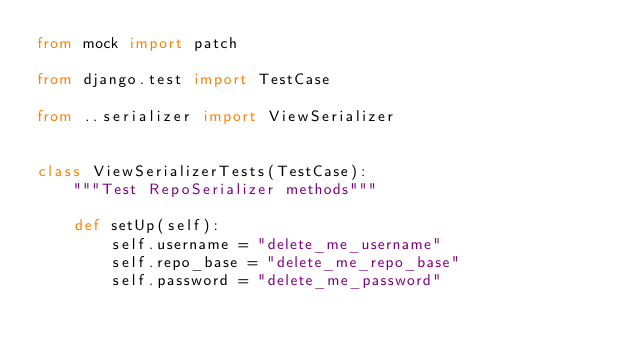Convert code to text. <code><loc_0><loc_0><loc_500><loc_500><_Python_>from mock import patch

from django.test import TestCase

from ..serializer import ViewSerializer


class ViewSerializerTests(TestCase):
    """Test RepoSerializer methods"""

    def setUp(self):
        self.username = "delete_me_username"
        self.repo_base = "delete_me_repo_base"
        self.password = "delete_me_password"
</code> 